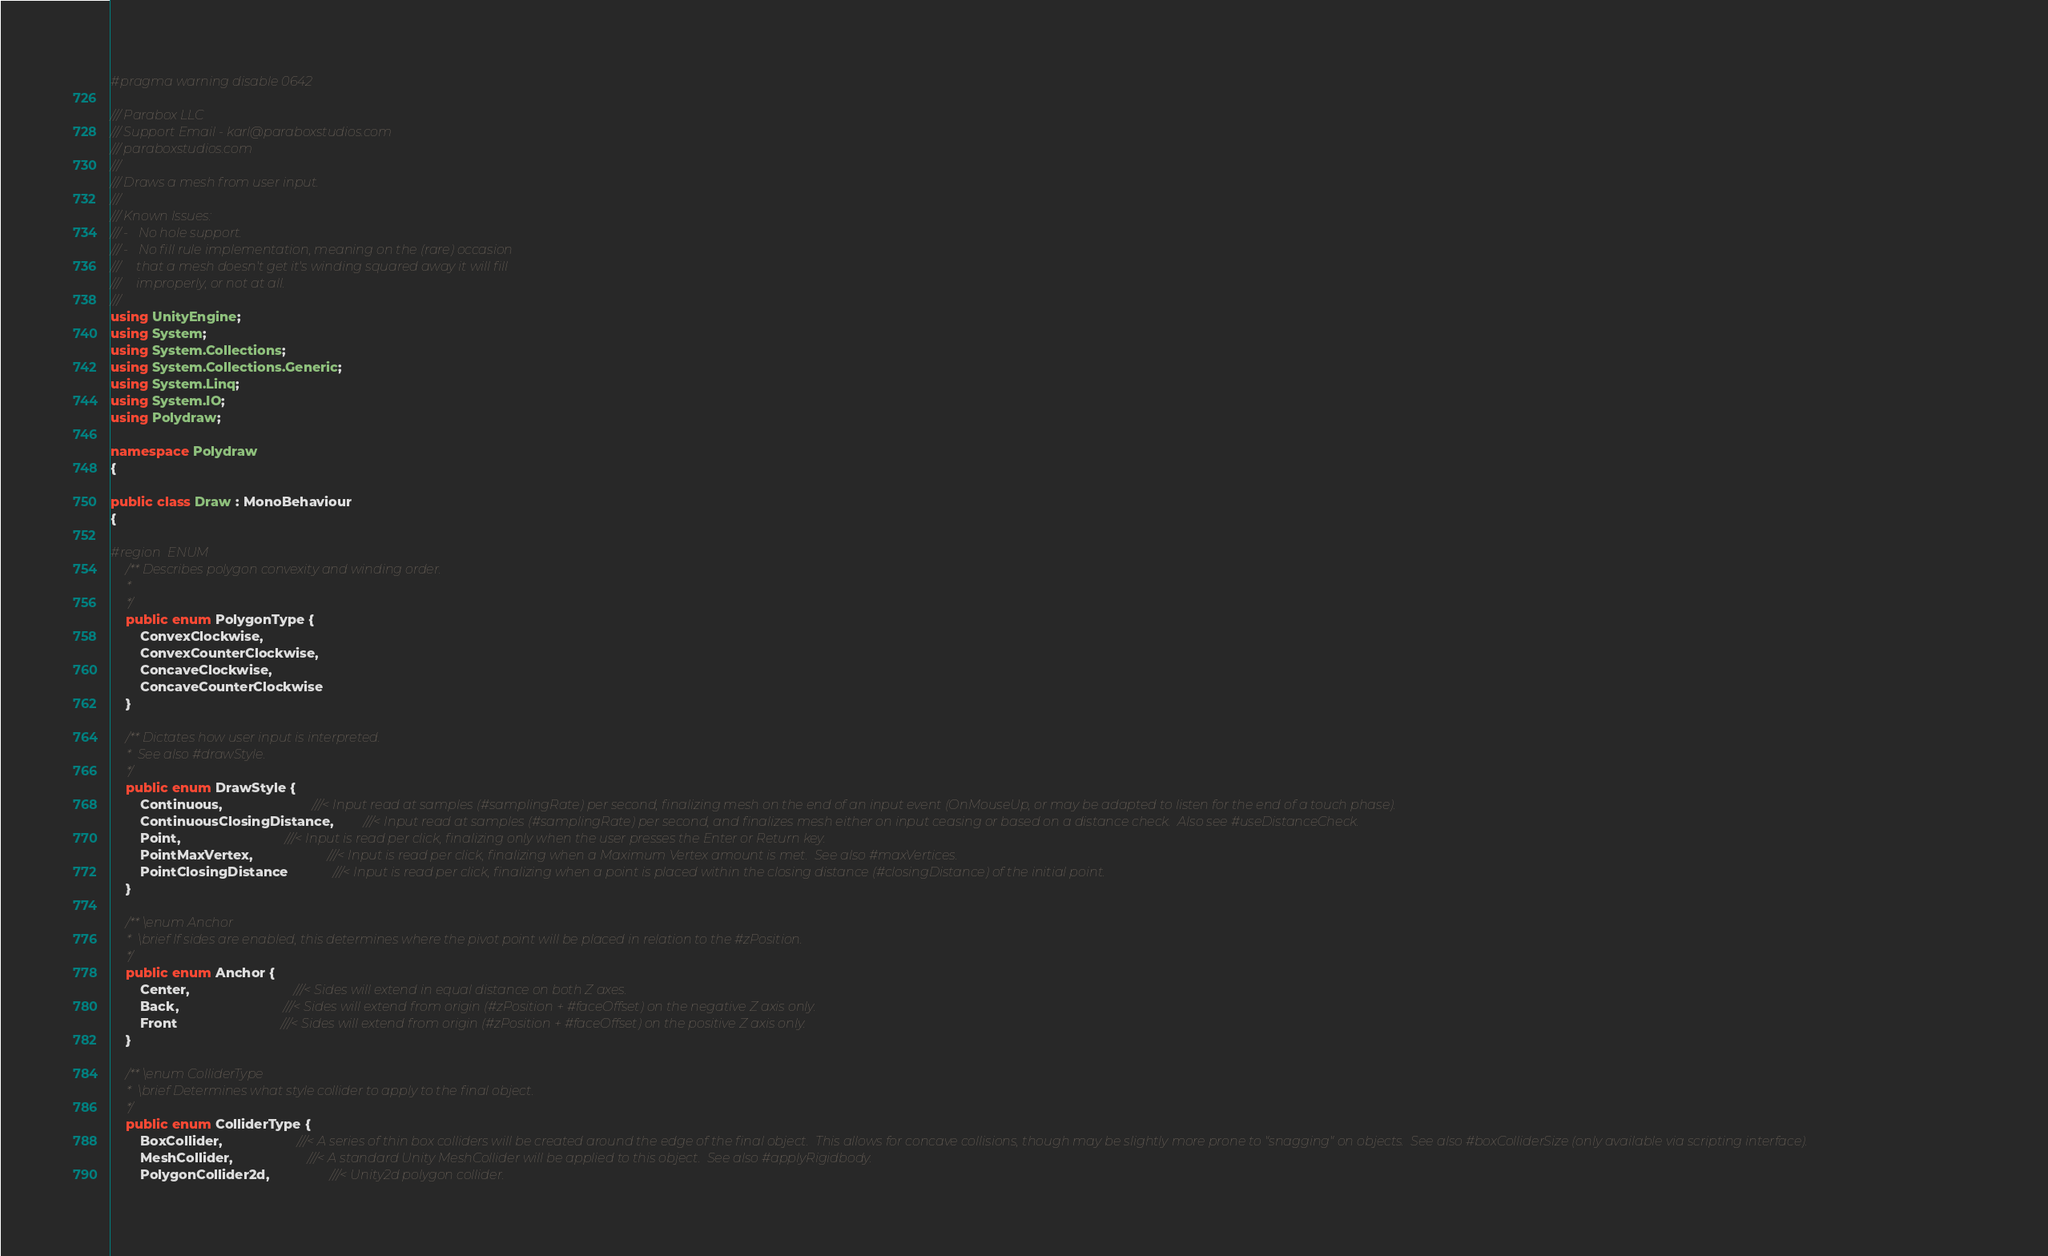<code> <loc_0><loc_0><loc_500><loc_500><_C#_>#pragma warning disable 0642

/// Parabox LLC
/// Support Email - karl@paraboxstudios.com
/// paraboxstudios.com
///
/// Draws a mesh from user input.
/// 
/// Known Issues:
/// -	No hole support.
///	-	No fill rule implementation, meaning on the (rare) occasion
///		that a mesh doesn't get it's winding squared away it will fill
///		improperly, or not at all.
/// 
using UnityEngine;
using System;
using System.Collections;
using System.Collections.Generic;
using System.Linq;
using System.IO;
using Polydraw;

namespace Polydraw
{

public class Draw : MonoBehaviour
{

#region ENUM
	/** Describes polygon convexity and winding order.
	 *
	 */
	public enum PolygonType {
		ConvexClockwise,
		ConvexCounterClockwise,
		ConcaveClockwise,
		ConcaveCounterClockwise
	}

	/** Dictates how user input is interpreted.
	 *	See also #drawStyle.
	 */
	public enum DrawStyle {
		Continuous,						///< Input read at samples (#samplingRate) per second, finalizing mesh on the end of an input event (OnMouseUp, or may be adapted to listen for the end of a touch phase).
		ContinuousClosingDistance,		///< Input read at samples (#samplingRate) per second, and finalizes mesh either on input ceasing or based on a distance check.  Also see #useDistanceCheck.
		Point,							///< Input is read per click, finalizing only when the user presses the Enter or Return key.
		PointMaxVertex,					///< Input is read per click, finalizing when a Maximum Vertex amount is met.  See also #maxVertices.
		PointClosingDistance			///< Input is read per click, finalizing when a point is placed within the closing distance (#closingDistance) of the initial point.
	}
	
	/** \enum Anchor 
	 *  \brief If sides are enabled, this determines where the pivot point will be placed in relation to the #zPosition.
	 */
	public enum Anchor {
		Center,							///< Sides will extend in equal distance on both Z axes.
		Back,							///< Sides will extend from origin (#zPosition + #faceOffset) on the negative Z axis only.
		Front 							///< Sides will extend from origin (#zPosition + #faceOffset) on the positive Z axis only.
	}

	/** \enum ColliderType
	 *	\brief Determines what style collider to apply to the final object.
	 */
	public enum ColliderType {
		BoxCollider,					///< A series of thin box colliders will be created around the edge of the final object.  This allows for concave collisions, though may be slightly more prone to "snagging" on objects.  See also #boxColliderSize (only available via scripting interface).
		MeshCollider,					///< A standard Unity MeshCollider will be applied to this object.  See also #applyRigidbody.
		PolygonCollider2d,				///< Unity2d polygon collider.</code> 